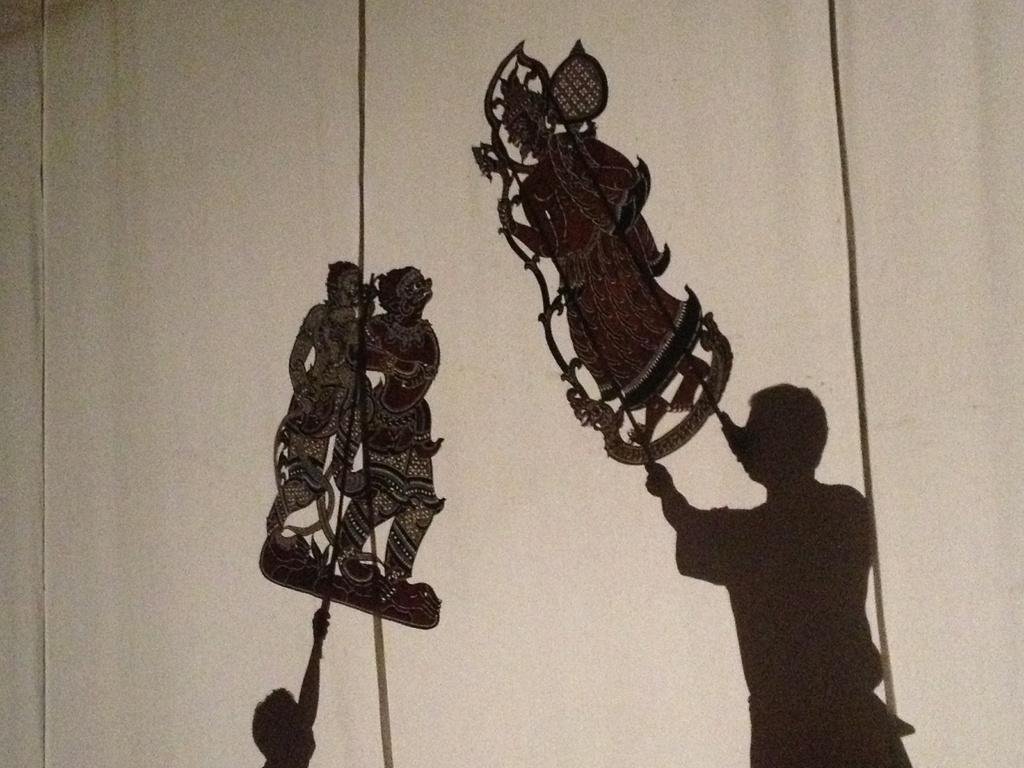Who is present in the image? There is a person and a boy in the image. What are they doing together? They are playing a puppet show. Where is the puppet show taking place? The puppet show is taking place at the backside of a curtain. What type of beetle can be seen crawling on the boy's apparel in the image? There is no beetle present in the image, and the boy's apparel is not mentioned in the provided facts. 